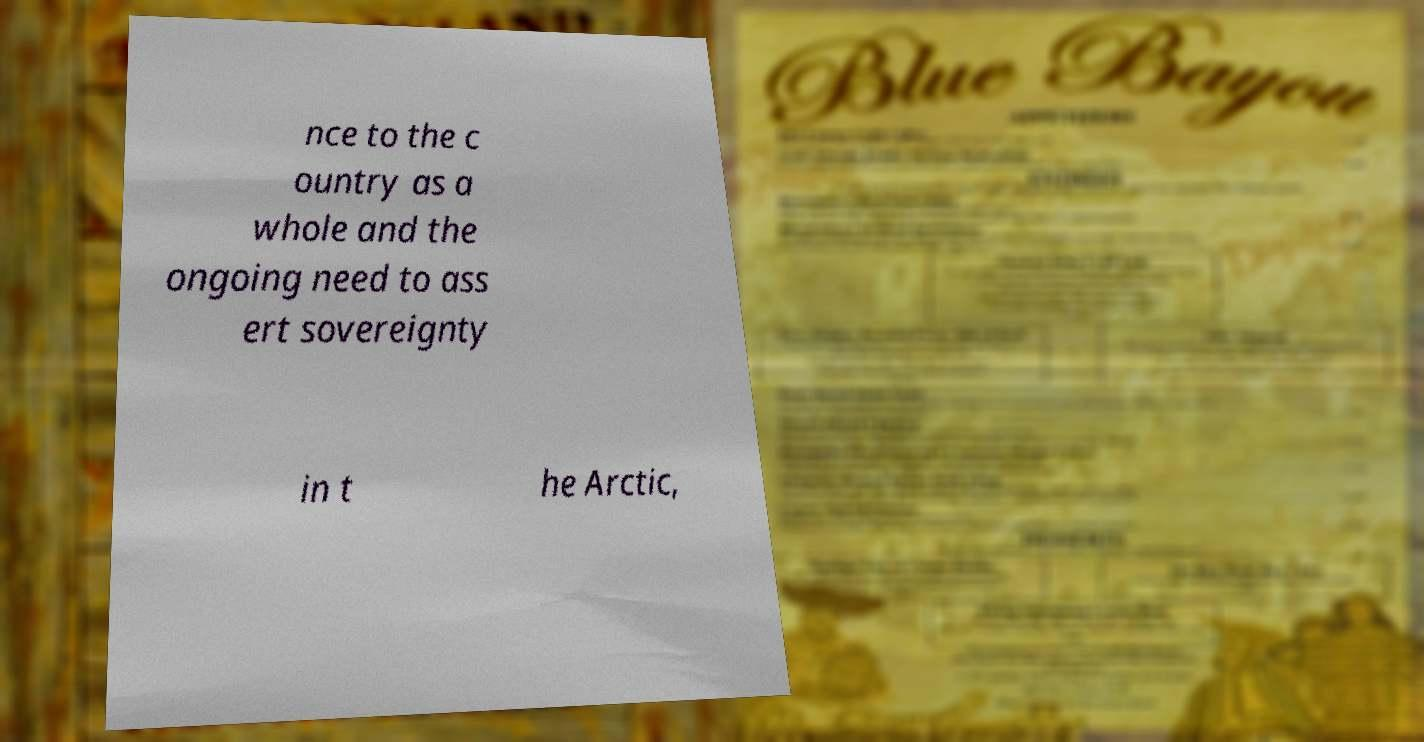Can you accurately transcribe the text from the provided image for me? nce to the c ountry as a whole and the ongoing need to ass ert sovereignty in t he Arctic, 